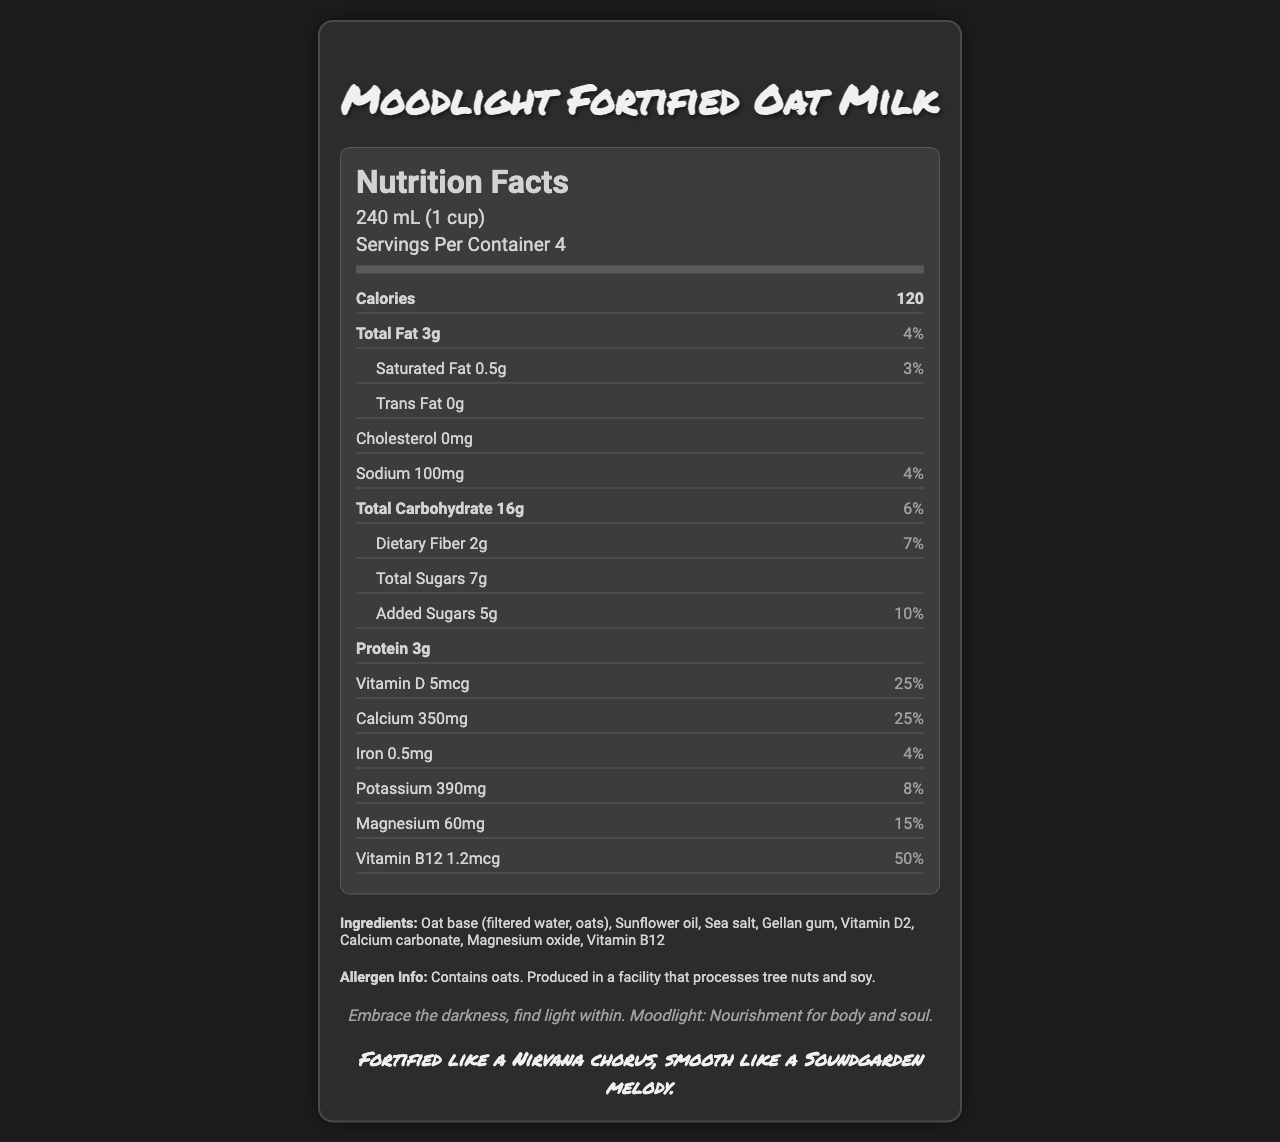what is the product name? The product name is displayed at the top of the document.
Answer: Moodlight Fortified Oat Milk what is the serving size? The serving size is indicated in the section where the product name and serving information are listed.
Answer: 240 mL (1 cup) how many servings are per container? The number of servings per container is mentioned right below the serving size.
Answer: 4 how many calories are in one serving? The calorie count per serving is shown prominently in the nutrition facts section.
Answer: 120 what percentage of the daily value of vitamin D does this product provide per serving? The percentage of daily value for vitamin D is listed in the nutrition facts section next to its amount.
Answer: 25% which ingredient is listed first? The first ingredient listed in the ingredients section is Oat base (filtered water, oats).
Answer: Oat base (filtered water, oats) how much sodium is in one serving? The amount of sodium per serving is detailed in the nutrition facts section.
Answer: 100mg which ingredient contributes to the presence of vitamin D and magnesium? A. Calcium carbonate B. Vitamin D2 C. Magnesium oxide D. Sunflower oil Vitamin D2 contributes vitamin D, and Magnesium oxide contributes magnesium, as mentioned in the ingredients list.
Answer: B and C what is the suggested health benefit of this product? The health claim stated at the end of the nutrition facts section mentions this benefit explicitly.
Answer: Vitamin D and magnesium may contribute to improved mood and emotional well-being. which of the following nutrients does this product do *not* contain? A. Cholesterol B. Trans Fat C. Fiber D. Protein The product contains cholesterol as one of its nutrients as shown in the document.
Answer: A is there any information about allergens in this product? The allergen information is found towards the end of the document and mentions that it contains oats and is produced in a facility that processes tree nuts and soy.
Answer: Yes summarize the main nutritional and ingredient features of this product. This product offers a blend of nutritional benefits, including significant percentages of vitamin D, magnesium, and vitamin B12, while being a non-dairy alternative suitable for those avoiding cholesterol and trans fats. The ingredients highlight an oat base and additional fortifications for health benefits.
Answer: Moodlight Fortified Oat Milk, a non-dairy milk alternative, provides 120 calories per 240mL serving and includes essential nutrients such as vitamin D (25% DV), magnesium (15% DV), and vitamin B12 (50% DV). Made primarily of an oat base, it contains 3g of total fat, 100mg of sodium, 16g of carbohydrates, and 3g of protein. The milk is designed to improve mood and emotional well-being. is there any cholesterol in Moodlight Fortified Oat Milk? The nutrition facts section explicitly states that the cholesterol content is 0mg.
Answer: No how much dietary fiber is there per serving and what percentage of daily value does it represent? The dietary fiber content and its corresponding daily value percentage are given in the nutrition facts section.
Answer: 2g, 7% how is the product Moodlight Fortified Oat Milk described by the brand? The brand message and tagline sections provide this detailed description.
Answer: Embrace the darkness, find light within. Moodlight: Nourishment for body and soul. Fortified like a Nirvana chorus, smooth like a Soundgarden melody. what is the exact amount of potassium in a serving? The potassium amount per serving is specified in the nutrition facts section.
Answer: 390mg what is the relationship between vitamin D and emotional well-being suggested in the document? The document suggests this relationship explicitly in the health claim section.
Answer: Vitamin D and magnesium may contribute to improved mood and emotional well-being. how many grams of added sugars are per serving, and what is the percentage of the daily value? The added sugars per serving and their daily value percentage are shown in the nutrition facts section.
Answer: 5g, 10% how many grams of saturated fat does this product have per serving? The amount of saturated fat in one serving is stated in the nutrition facts section.
Answer: 0.5g does the document mention if the product is suitable for someone with a nut allergy? The document mentions that it is produced in a facility that processes tree nuts and soy. It does not explicitly state that the product is free from nuts.
Answer: Not enough information how many milligrams of calcium are in one serving? The calcium content per serving is provided in the nutrition facts section as 350mg (25% DV).
Answer: 350mg 